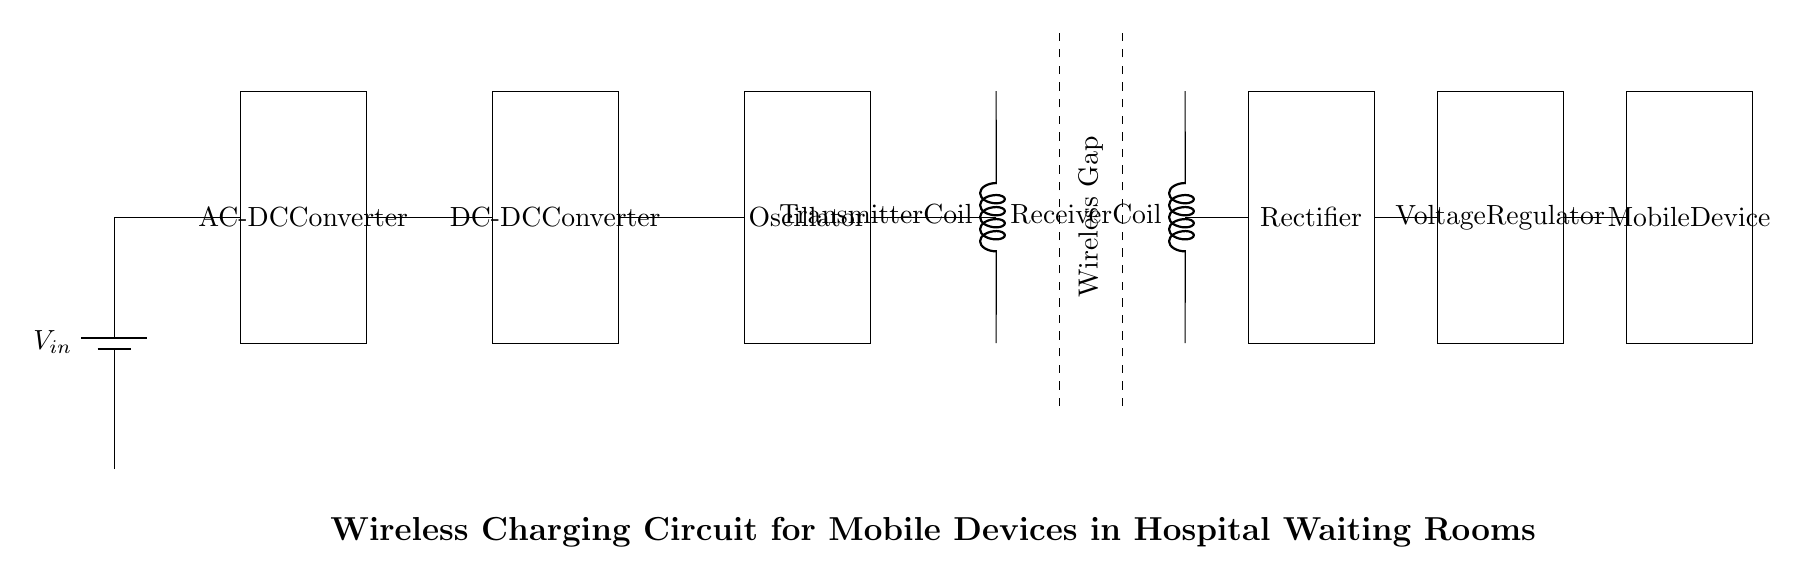What is the type of battery used in this circuit? The circuit diagram shows a battery symbol labeled as $V_{in}$, indicating the type of power source.
Answer: battery What is the role of the AC-DC converter in this circuit? The AC-DC converter in the circuit takes the alternating current from the battery and converts it into direct current, which is necessary for the subsequent circuit components.
Answer: power conversion How many coils are present in this wireless charging circuit? The circuit diagram clearly shows two coils: a transmitter coil and a receiver coil. Counting these gives us two coils.
Answer: two Why is there a wireless gap in the circuit? The wireless gap indicates the space in which wireless power transfer occurs between the transmitter coil and the receiver coil, allowing for non-contact charging.
Answer: wireless power transfer What component regulates the voltage for the mobile device? The voltage regulator is the component that ensures the voltage supplied to the mobile device remains stable and within acceptable limits after rectification.
Answer: voltage regulator What is the function of the rectifier in this circuit? The rectifier converts the alternating current output from the receiver coil back into direct current, making it usable for charging the mobile device.
Answer: current conversion 